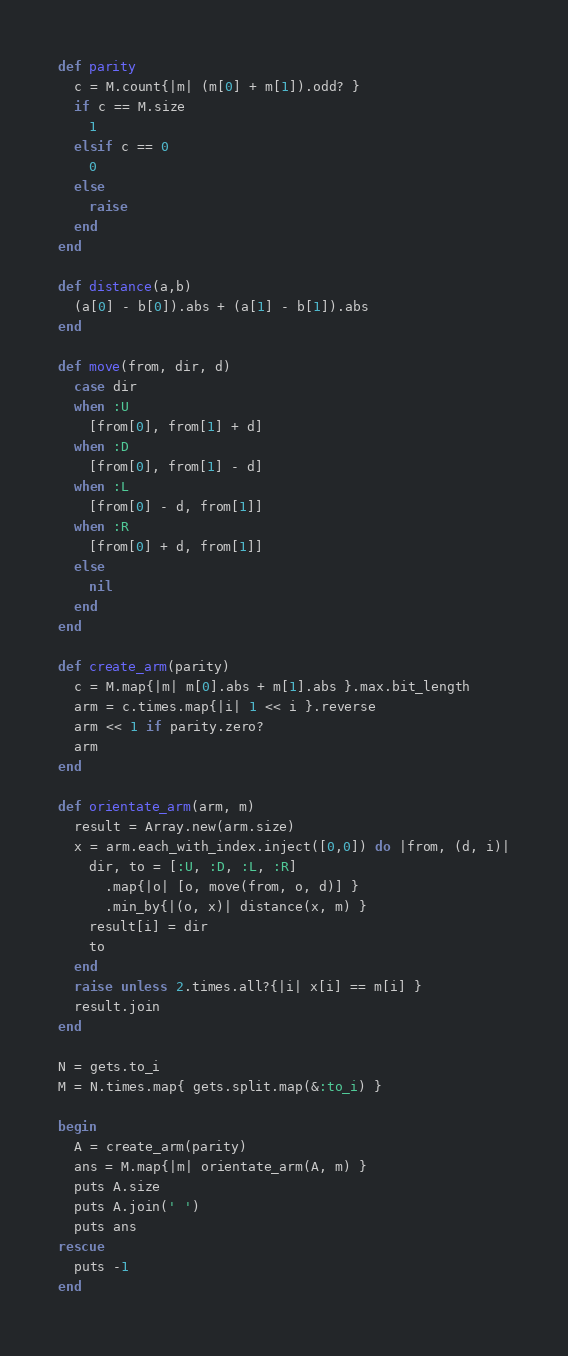Convert code to text. <code><loc_0><loc_0><loc_500><loc_500><_Ruby_>def parity
  c = M.count{|m| (m[0] + m[1]).odd? }
  if c == M.size
    1
  elsif c == 0
    0
  else
    raise
  end
end

def distance(a,b)
  (a[0] - b[0]).abs + (a[1] - b[1]).abs
end

def move(from, dir, d)
  case dir
  when :U
    [from[0], from[1] + d]
  when :D
    [from[0], from[1] - d]
  when :L
    [from[0] - d, from[1]]
  when :R
    [from[0] + d, from[1]]
  else
    nil
  end
end

def create_arm(parity)
  c = M.map{|m| m[0].abs + m[1].abs }.max.bit_length
  arm = c.times.map{|i| 1 << i }.reverse
  arm << 1 if parity.zero?
  arm
end

def orientate_arm(arm, m)
  result = Array.new(arm.size)
  x = arm.each_with_index.inject([0,0]) do |from, (d, i)|
    dir, to = [:U, :D, :L, :R]
      .map{|o| [o, move(from, o, d)] }
      .min_by{|(o, x)| distance(x, m) }
    result[i] = dir
    to
  end
  raise unless 2.times.all?{|i| x[i] == m[i] }
  result.join
end

N = gets.to_i
M = N.times.map{ gets.split.map(&:to_i) }

begin
  A = create_arm(parity)
  ans = M.map{|m| orientate_arm(A, m) }
  puts A.size
  puts A.join(' ')
  puts ans
rescue
  puts -1
end

</code> 